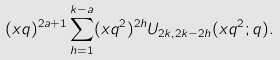Convert formula to latex. <formula><loc_0><loc_0><loc_500><loc_500>( x q ) ^ { 2 a + 1 } \sum _ { h = 1 } ^ { k - a } ( x q ^ { 2 } ) ^ { 2 h } U _ { 2 k , 2 k - 2 h } ( x q ^ { 2 } ; q ) .</formula> 